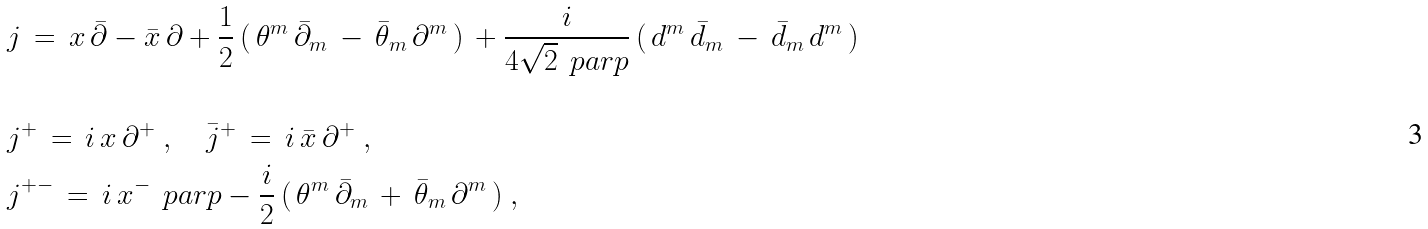<formula> <loc_0><loc_0><loc_500><loc_500>& j \, = \, x \, \bar { \partial } - \bar { x } \, \partial + \frac { 1 } { 2 } \, ( \, \theta ^ { m } \, { \bar { \partial } } _ { m } \, - \, { \bar { \theta } } _ { m } \, \partial ^ { m } \, ) \, + \frac { i } { 4 \sqrt { 2 } \, \ p a r p } \, ( \, d ^ { m } \, { \bar { d } } _ { m } \, - \, { \bar { d } } _ { m } \, d ^ { m } \, ) \ \\ \\ & j ^ { + } \, = \, i \, x \, \partial ^ { + } \ , \quad \bar { j } ^ { + } \, = \, i \, \bar { x } \, \partial ^ { + } \ , \\ & j ^ { + - } \, = \, i \, x ^ { - } \, \ p a r p - \frac { i } { 2 } \, ( \, \theta ^ { m } \, { \bar { \partial } } _ { m } \, + \, { \bar { \theta } } _ { m } \, \partial ^ { m } \, ) \ , \\ \\</formula> 